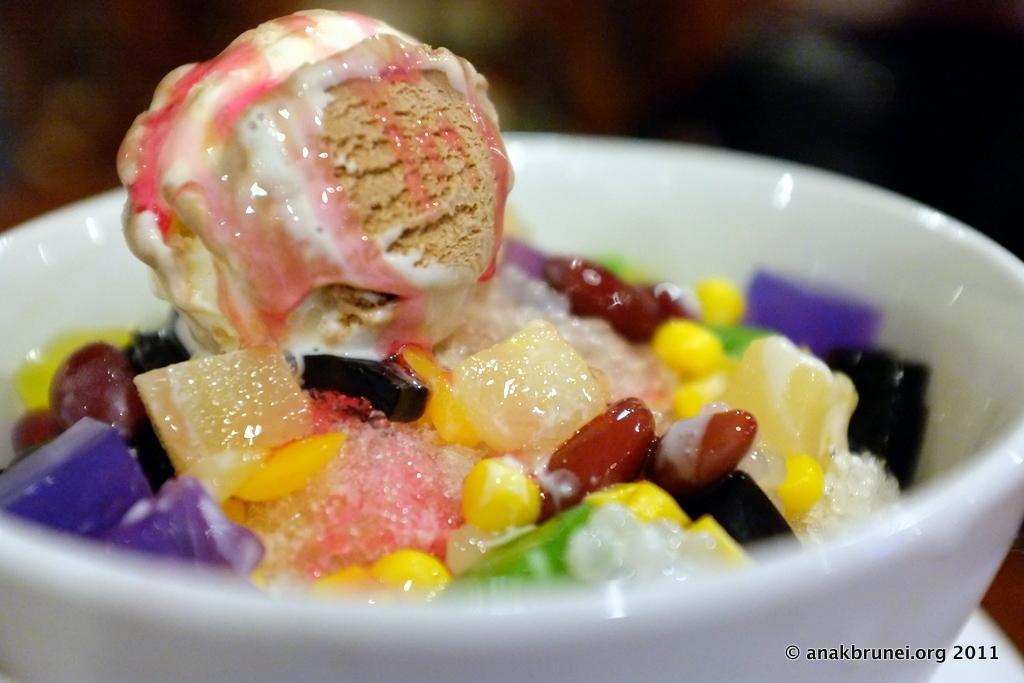Describe this image in one or two sentences. In this image we can see some food in the bowl. There is some text at the bottom of the image. There is a blur background at the top of the image. 